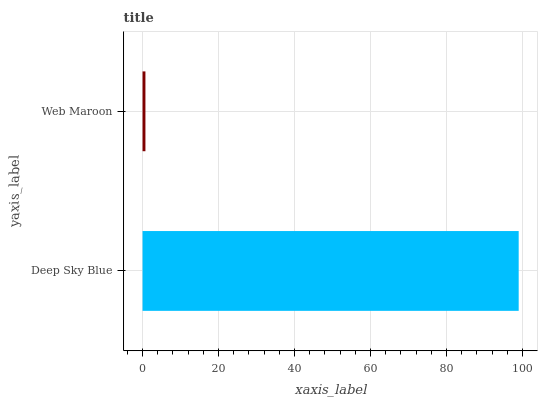Is Web Maroon the minimum?
Answer yes or no. Yes. Is Deep Sky Blue the maximum?
Answer yes or no. Yes. Is Web Maroon the maximum?
Answer yes or no. No. Is Deep Sky Blue greater than Web Maroon?
Answer yes or no. Yes. Is Web Maroon less than Deep Sky Blue?
Answer yes or no. Yes. Is Web Maroon greater than Deep Sky Blue?
Answer yes or no. No. Is Deep Sky Blue less than Web Maroon?
Answer yes or no. No. Is Deep Sky Blue the high median?
Answer yes or no. Yes. Is Web Maroon the low median?
Answer yes or no. Yes. Is Web Maroon the high median?
Answer yes or no. No. Is Deep Sky Blue the low median?
Answer yes or no. No. 